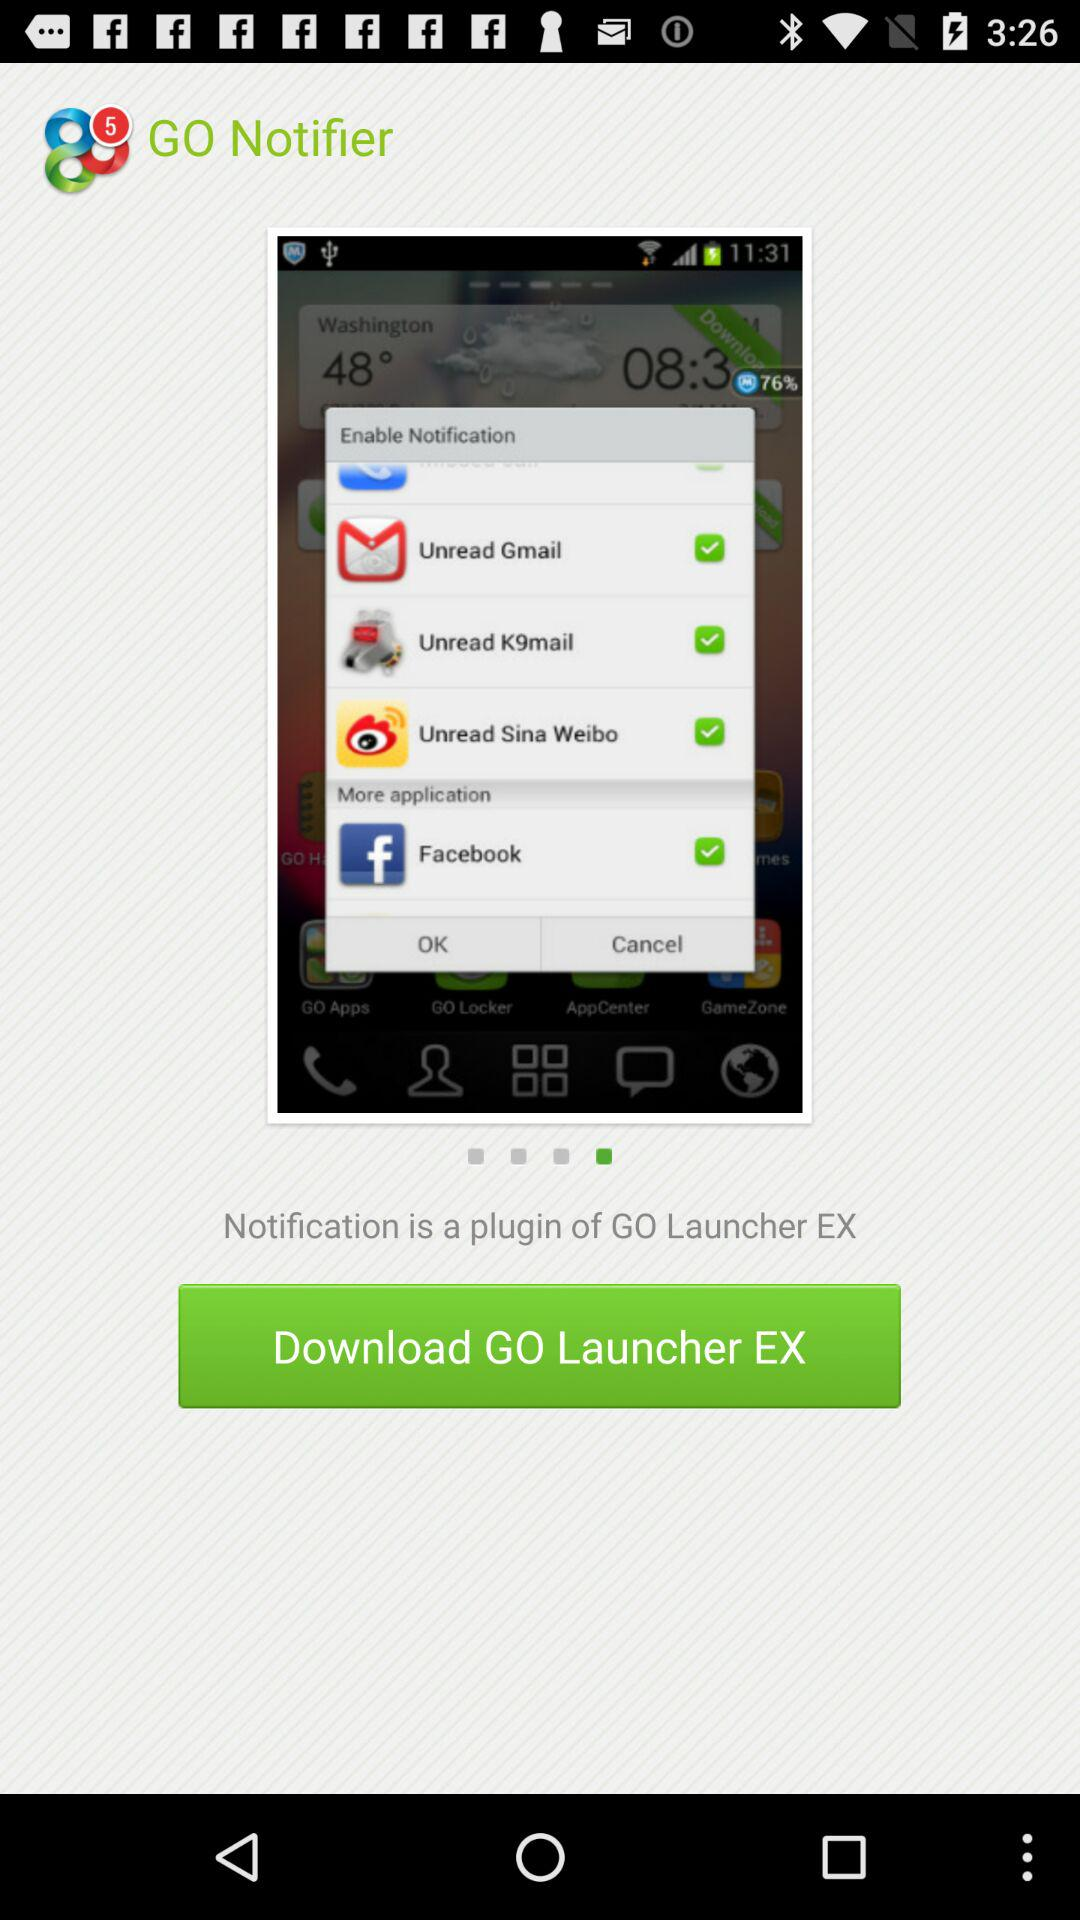What is the selected checkbox? The selected checkboxes are "Unread Gmail", "Unread K9mail", "Unread Sina Weibo" and "Facebook". 